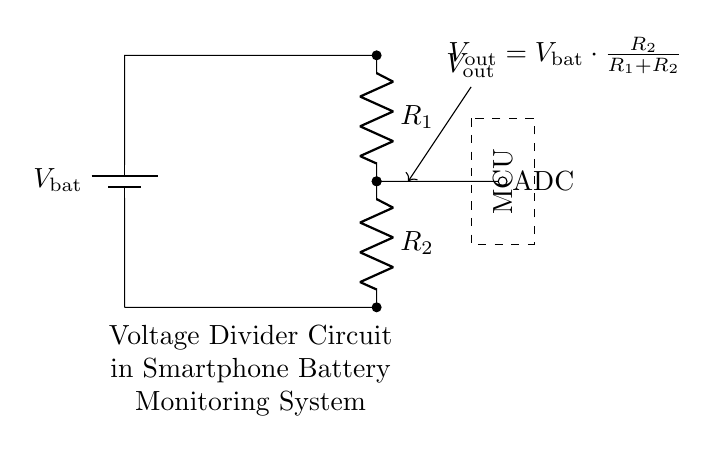What is the type of the voltage source in this circuit? The circuit diagram shows a battery labeled as V_bat, indicating it is a direct current voltage source as used in smartphone battery monitoring systems.
Answer: battery What are the two resistors labeled in the circuit? The circuit has two resistors, R1 and R2, connected in series. This indicates they play a crucial role in forming the voltage divider.
Answer: R1 and R2 What is the output voltage formula shown in the diagram? The output voltage formula provided in the diagram indicates how V_out relates to the total voltage and the resistor values: V_out = V_bat * (R2 / (R1 + R2)). This equation is central to how voltage dividers are calculated.
Answer: V_out = V_bat * R2 / (R1 + R2) Where does the output voltage V_out connect to in the circuit? The output voltage V_out is connected to an ADC (Analog-to-Digital Converter), indicating this voltage will be read or processed by the microcontroller unit (MCU).
Answer: ADC What is the relationship between the resistors R1 and R2 in determining V_out? R2 is used to determine the proportion of the total voltage V_bat that appears at V_out, while R1 affects the voltage division ratio. Smaller R1 relative to R2 results in higher output voltage.
Answer: V_out = V_bat * R2 / (R1 + R2) 